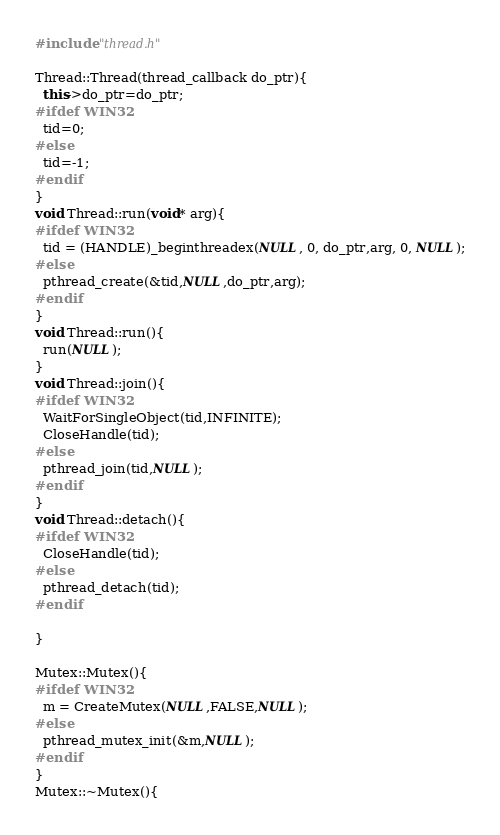<code> <loc_0><loc_0><loc_500><loc_500><_C++_>#include "thread.h"

Thread::Thread(thread_callback do_ptr){
  this->do_ptr=do_ptr;
#ifdef WIN32
  tid=0;
#else
  tid=-1;
#endif
}
void Thread::run(void* arg){
#ifdef WIN32
  tid = (HANDLE)_beginthreadex(NULL, 0, do_ptr,arg, 0, NULL);
#else
  pthread_create(&tid,NULL,do_ptr,arg);
#endif
}
void Thread::run(){
  run(NULL);
}
void Thread::join(){
#ifdef WIN32
  WaitForSingleObject(tid,INFINITE);
  CloseHandle(tid);
#else
  pthread_join(tid,NULL);
#endif
}
void Thread::detach(){
#ifdef WIN32
  CloseHandle(tid);
#else
  pthread_detach(tid);
#endif
    
}

Mutex::Mutex(){
#ifdef WIN32
  m = CreateMutex(NULL,FALSE,NULL);
#else
  pthread_mutex_init(&m,NULL);
#endif
}
Mutex::~Mutex(){</code> 